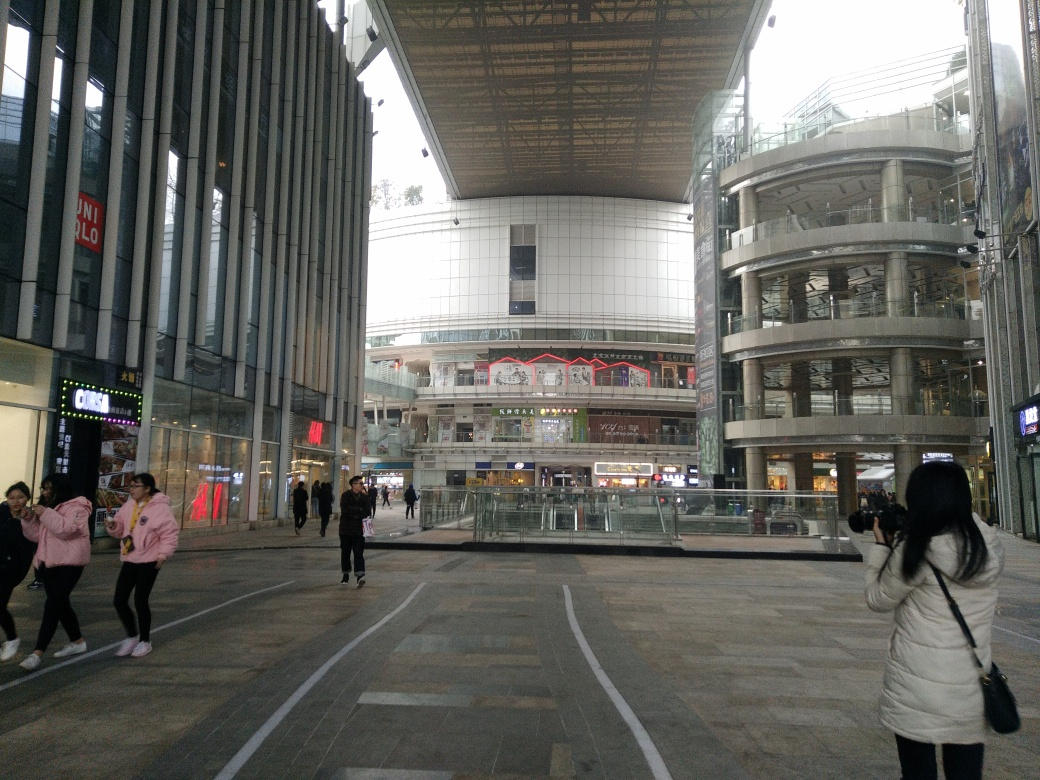What might be the function of this area? The area captured in the image seems to be a commercial plaza or shopping center. The presence of visible brand signage, such as UNIQLO, and the layout designed to facilitate foot traffic suggest that this space is intended for retail and possibly dining, catering to a high volume of shoppers and visitors. What indicates that this photo is taken in a place with high foot traffic? Indicators of high foot traffic include the wide pedestrian pathways, the open space allowing for groups of people to pass through or gather, various shop fronts designed to attract passersby, and the presence of multiple people in the scene, some of whom are walking or engaged in photography, suggesting tourist or shopper activity. 